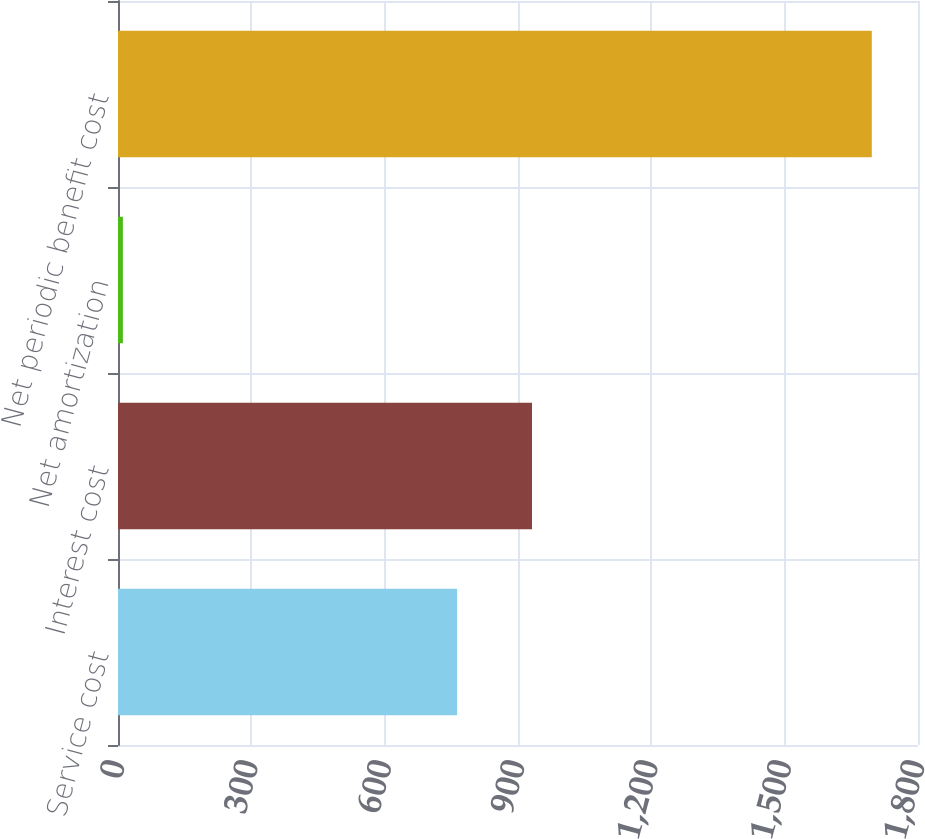Convert chart to OTSL. <chart><loc_0><loc_0><loc_500><loc_500><bar_chart><fcel>Service cost<fcel>Interest cost<fcel>Net amortization<fcel>Net periodic benefit cost<nl><fcel>763<fcel>931.5<fcel>11<fcel>1696<nl></chart> 